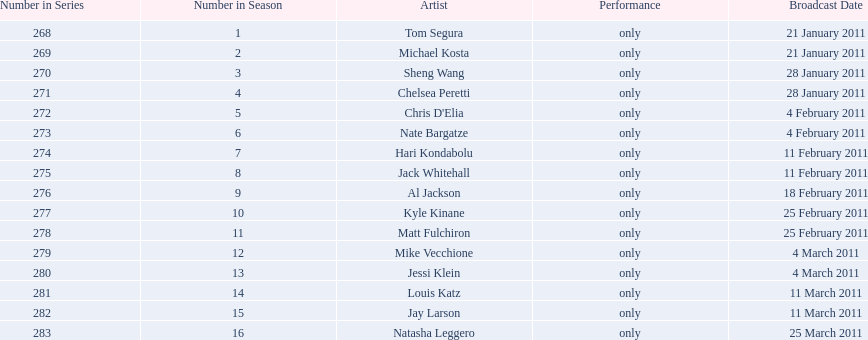What is the name of the last performer on this chart? Natasha Leggero. Would you mind parsing the complete table? {'header': ['Number in Series', 'Number in Season', 'Artist', 'Performance', 'Broadcast Date'], 'rows': [['268', '1', 'Tom Segura', 'only', '21 January 2011'], ['269', '2', 'Michael Kosta', 'only', '21 January 2011'], ['270', '3', 'Sheng Wang', 'only', '28 January 2011'], ['271', '4', 'Chelsea Peretti', 'only', '28 January 2011'], ['272', '5', "Chris D'Elia", 'only', '4 February 2011'], ['273', '6', 'Nate Bargatze', 'only', '4 February 2011'], ['274', '7', 'Hari Kondabolu', 'only', '11 February 2011'], ['275', '8', 'Jack Whitehall', 'only', '11 February 2011'], ['276', '9', 'Al Jackson', 'only', '18 February 2011'], ['277', '10', 'Kyle Kinane', 'only', '25 February 2011'], ['278', '11', 'Matt Fulchiron', 'only', '25 February 2011'], ['279', '12', 'Mike Vecchione', 'only', '4 March 2011'], ['280', '13', 'Jessi Klein', 'only', '4 March 2011'], ['281', '14', 'Louis Katz', 'only', '11 March 2011'], ['282', '15', 'Jay Larson', 'only', '11 March 2011'], ['283', '16', 'Natasha Leggero', 'only', '25 March 2011']]} 